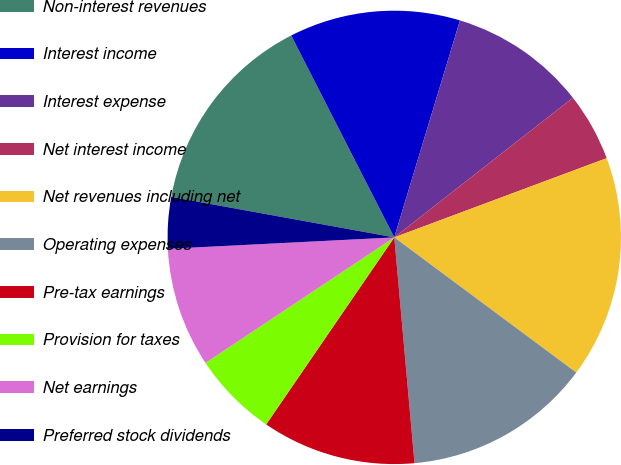<chart> <loc_0><loc_0><loc_500><loc_500><pie_chart><fcel>Non-interest revenues<fcel>Interest income<fcel>Interest expense<fcel>Net interest income<fcel>Net revenues including net<fcel>Operating expenses<fcel>Pre-tax earnings<fcel>Provision for taxes<fcel>Net earnings<fcel>Preferred stock dividends<nl><fcel>14.63%<fcel>12.19%<fcel>9.76%<fcel>4.88%<fcel>15.85%<fcel>13.41%<fcel>10.98%<fcel>6.1%<fcel>8.54%<fcel>3.66%<nl></chart> 